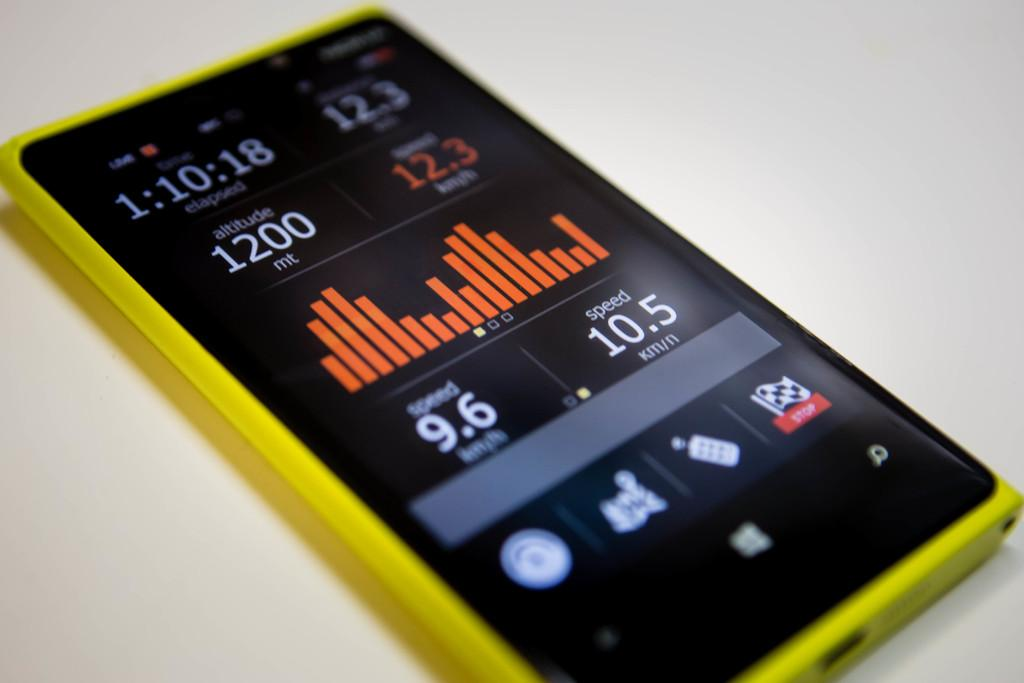<image>
Give a short and clear explanation of the subsequent image. a phone with the word 1200 on it 